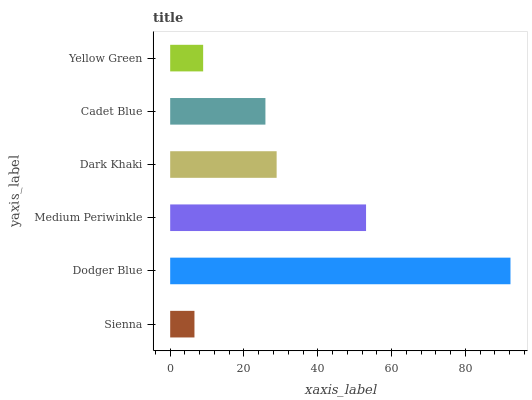Is Sienna the minimum?
Answer yes or no. Yes. Is Dodger Blue the maximum?
Answer yes or no. Yes. Is Medium Periwinkle the minimum?
Answer yes or no. No. Is Medium Periwinkle the maximum?
Answer yes or no. No. Is Dodger Blue greater than Medium Periwinkle?
Answer yes or no. Yes. Is Medium Periwinkle less than Dodger Blue?
Answer yes or no. Yes. Is Medium Periwinkle greater than Dodger Blue?
Answer yes or no. No. Is Dodger Blue less than Medium Periwinkle?
Answer yes or no. No. Is Dark Khaki the high median?
Answer yes or no. Yes. Is Cadet Blue the low median?
Answer yes or no. Yes. Is Cadet Blue the high median?
Answer yes or no. No. Is Sienna the low median?
Answer yes or no. No. 